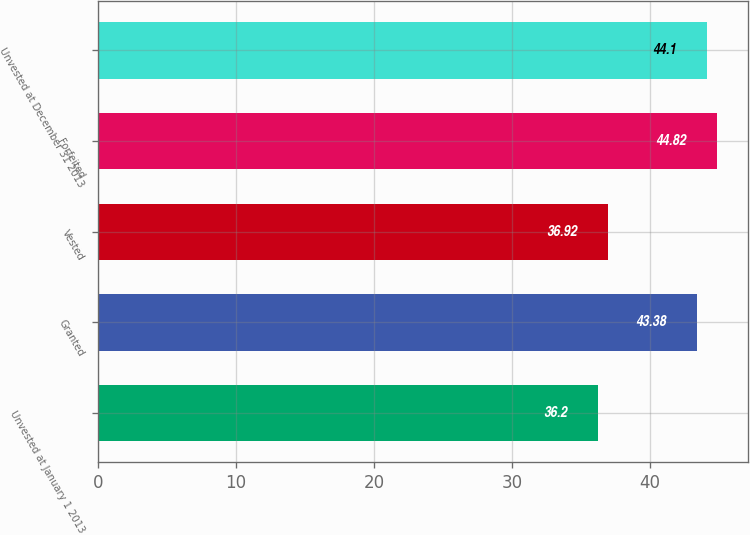Convert chart to OTSL. <chart><loc_0><loc_0><loc_500><loc_500><bar_chart><fcel>Unvested at January 1 2013<fcel>Granted<fcel>Vested<fcel>Forfeited<fcel>Unvested at December 31 2013<nl><fcel>36.2<fcel>43.38<fcel>36.92<fcel>44.82<fcel>44.1<nl></chart> 